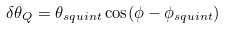<formula> <loc_0><loc_0><loc_500><loc_500>\delta \theta _ { Q } = \theta _ { s q u i n t } \cos ( \phi - \phi _ { s q u i n t } )</formula> 